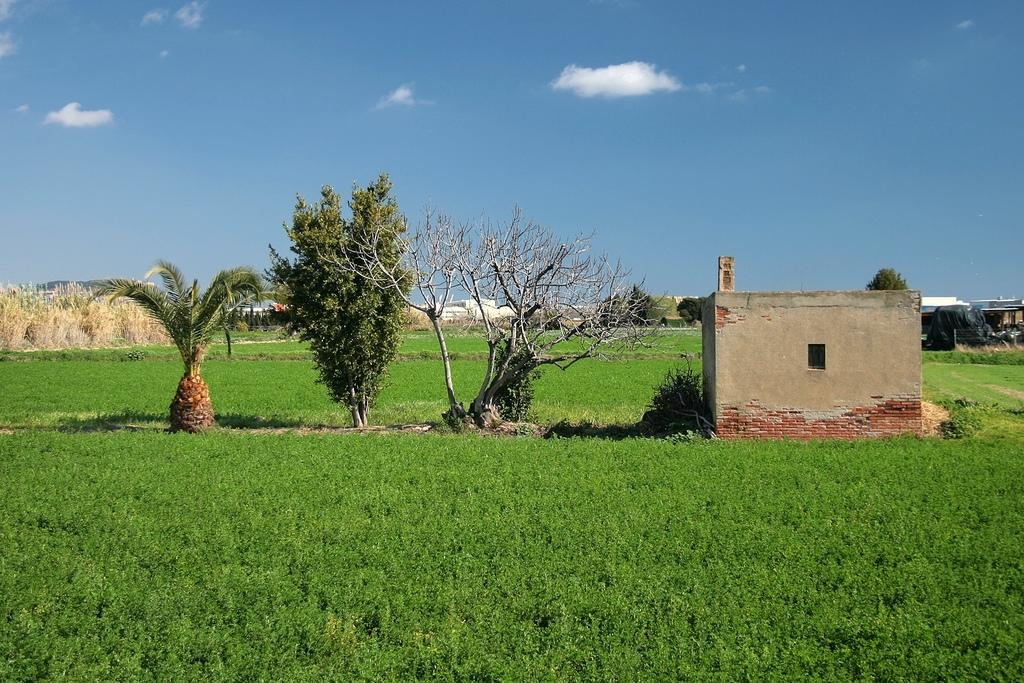What type of vegetation can be seen in the image? There are trees in the image. What type of structure is visible in the image? There is a house in the image. What is the condition of the ground in the image? Dry grass is present in the image. How would you describe the color of the sky in the image? The sky is a combination of white and blue colors. Can you tell me what type of answer the lawyer is giving in the image? There is no lawyer or answer present in the image; it only features trees, a house, dry grass, and a sky with white and blue colors. What type of screw can be seen holding the house together in the image? There are no screws visible in the image; the house appears to be a solid structure. 